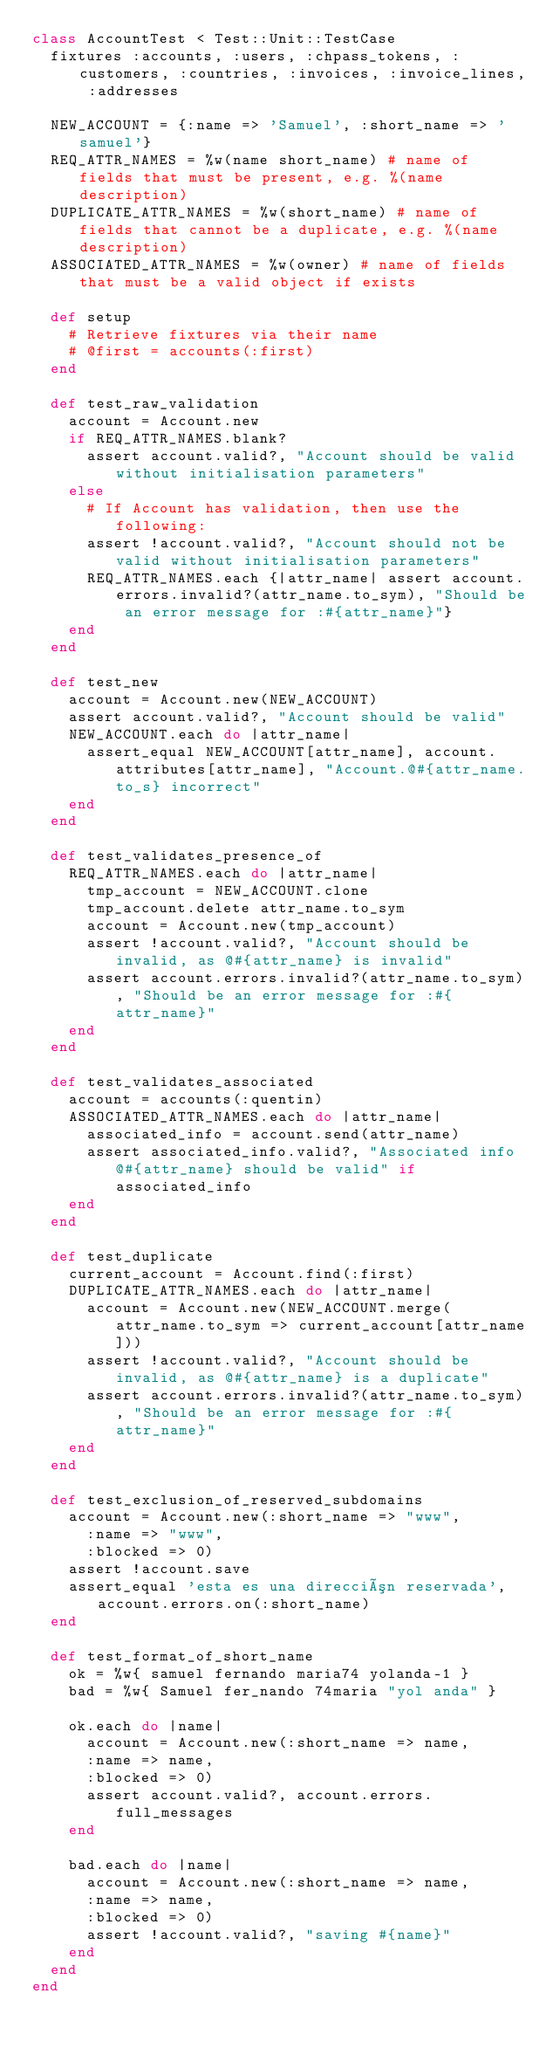<code> <loc_0><loc_0><loc_500><loc_500><_Ruby_>class AccountTest < Test::Unit::TestCase
  fixtures :accounts, :users, :chpass_tokens, :customers, :countries, :invoices, :invoice_lines, :addresses

  NEW_ACCOUNT = {:name => 'Samuel', :short_name => 'samuel'}
  REQ_ATTR_NAMES = %w(name short_name) # name of fields that must be present, e.g. %(name description)
  DUPLICATE_ATTR_NAMES = %w(short_name) # name of fields that cannot be a duplicate, e.g. %(name description)
  ASSOCIATED_ATTR_NAMES = %w(owner) # name of fields that must be a valid object if exists
  
  def setup
    # Retrieve fixtures via their name
    # @first = accounts(:first)
  end

  def test_raw_validation
    account = Account.new
    if REQ_ATTR_NAMES.blank?
      assert account.valid?, "Account should be valid without initialisation parameters"
    else
      # If Account has validation, then use the following:
      assert !account.valid?, "Account should not be valid without initialisation parameters"
      REQ_ATTR_NAMES.each {|attr_name| assert account.errors.invalid?(attr_name.to_sym), "Should be an error message for :#{attr_name}"}
    end
  end

  def test_new
    account = Account.new(NEW_ACCOUNT)
    assert account.valid?, "Account should be valid"
    NEW_ACCOUNT.each do |attr_name|
      assert_equal NEW_ACCOUNT[attr_name], account.attributes[attr_name], "Account.@#{attr_name.to_s} incorrect"
    end
  end

  def test_validates_presence_of
    REQ_ATTR_NAMES.each do |attr_name|
      tmp_account = NEW_ACCOUNT.clone
      tmp_account.delete attr_name.to_sym
      account = Account.new(tmp_account)
      assert !account.valid?, "Account should be invalid, as @#{attr_name} is invalid"
      assert account.errors.invalid?(attr_name.to_sym), "Should be an error message for :#{attr_name}"
    end
  end
  
  def test_validates_associated
    account = accounts(:quentin)
    ASSOCIATED_ATTR_NAMES.each do |attr_name|
      associated_info = account.send(attr_name)
      assert associated_info.valid?, "Associated info @#{attr_name} should be valid" if associated_info
    end
  end

  def test_duplicate
    current_account = Account.find(:first)
    DUPLICATE_ATTR_NAMES.each do |attr_name|
      account = Account.new(NEW_ACCOUNT.merge(attr_name.to_sym => current_account[attr_name]))
      assert !account.valid?, "Account should be invalid, as @#{attr_name} is a duplicate"
      assert account.errors.invalid?(attr_name.to_sym), "Should be an error message for :#{attr_name}"
    end
  end
  
  def test_exclusion_of_reserved_subdomains
    account = Account.new(:short_name => "www",
      :name => "www",
      :blocked => 0)
    assert !account.save
    assert_equal 'esta es una dirección reservada', account.errors.on(:short_name)    
  end
  
  def test_format_of_short_name
    ok = %w{ samuel fernando maria74 yolanda-1 }
    bad = %w{ Samuel fer_nando 74maria "yol anda" }
    
    ok.each do |name|
      account = Account.new(:short_name => name,
      :name => name,
      :blocked => 0)
      assert account.valid?, account.errors.full_messages
    end
    
    bad.each do |name|
      account = Account.new(:short_name => name,
      :name => name,
      :blocked => 0)
      assert !account.valid?, "saving #{name}"
    end
  end
end

</code> 